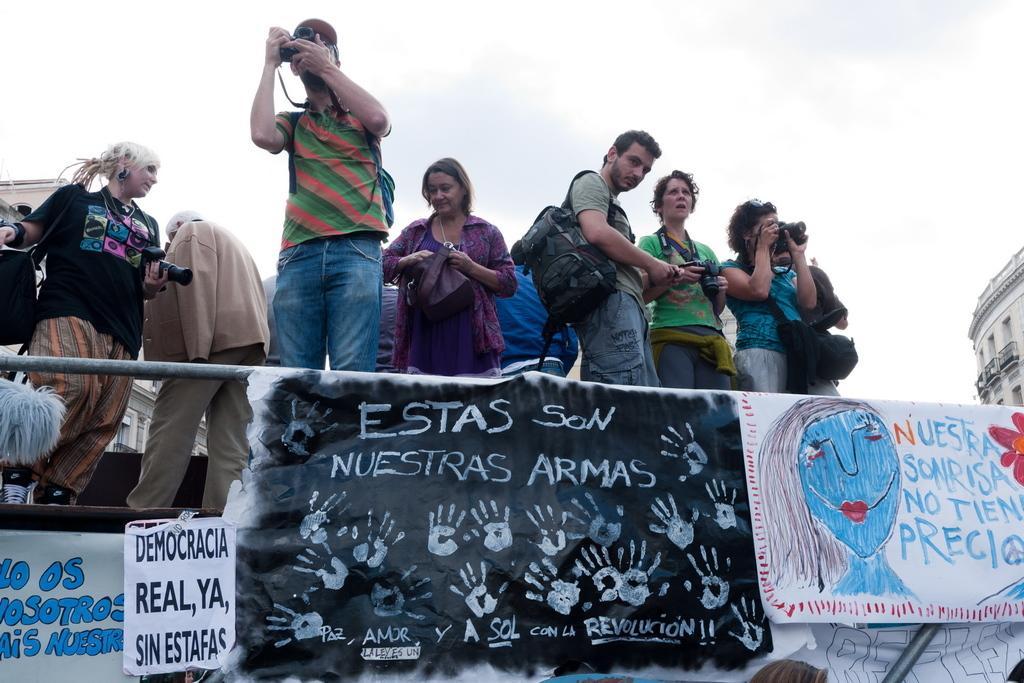Please provide a concise description of this image. In this picture in the front there are banners with some text written on it. In the center there are persons standing. On the right side there is a building and there are women standing and holding a camera in their hands. On the left side there is a woman walking and holding a camera in hand and in front of the woman in the center there is a man standing and clicking a photo in a camera. In the background there is a building and the sky is cloudy. 